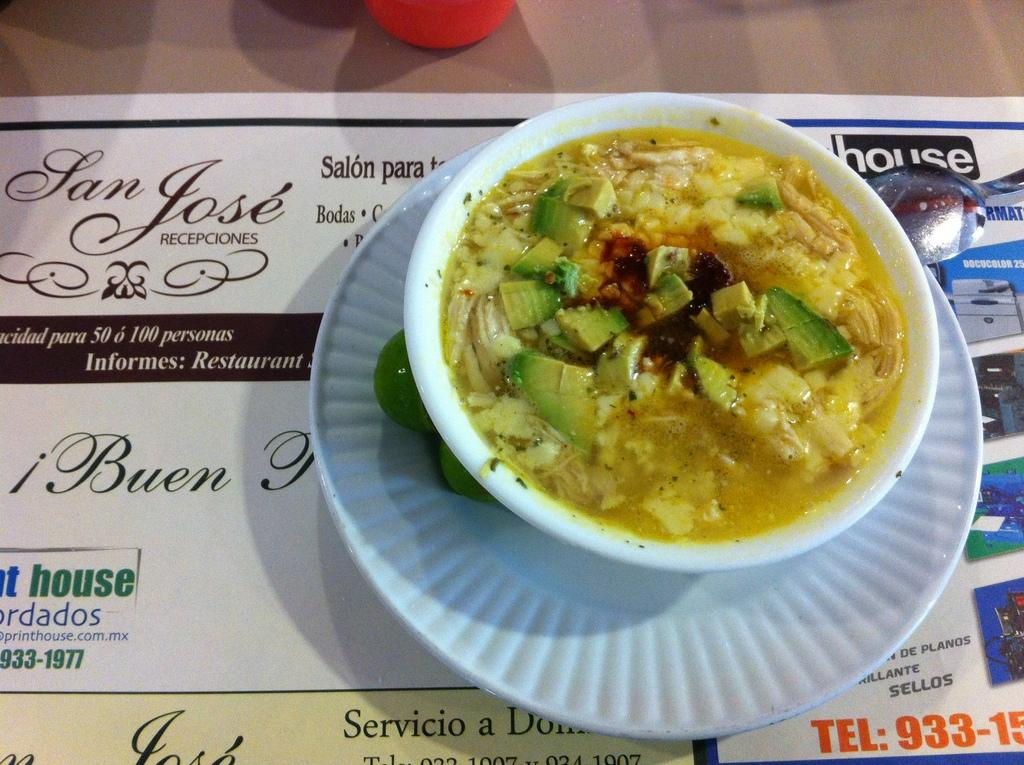What type of food is on the plate in the image? There is a soup on a plate in the image. Where is the spoon located in the image? The spoon is in the top right-hand corner of the image. What type of chalk is being used to draw on the plate in the image? There is no chalk or drawing present in the image; it only features a soup on a plate and a spoon. 